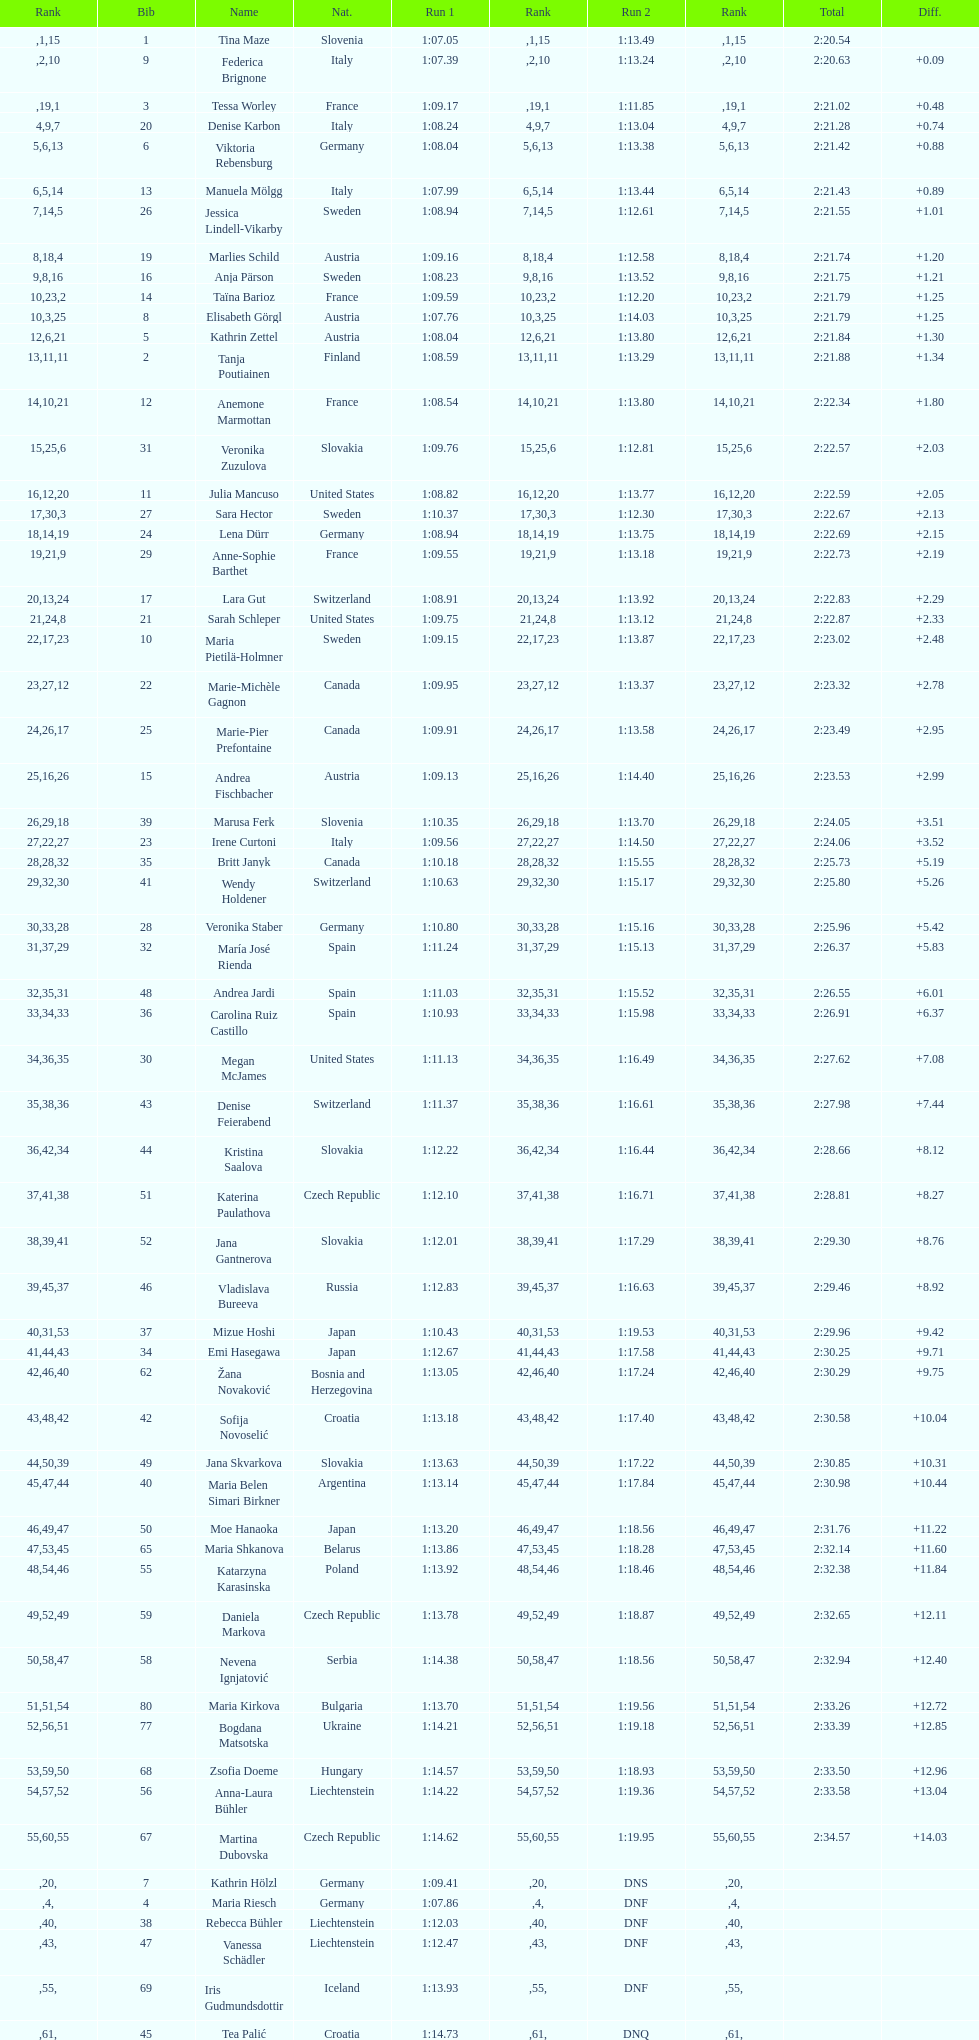Who was the last competitor to actually finish both runs? Martina Dubovska. 